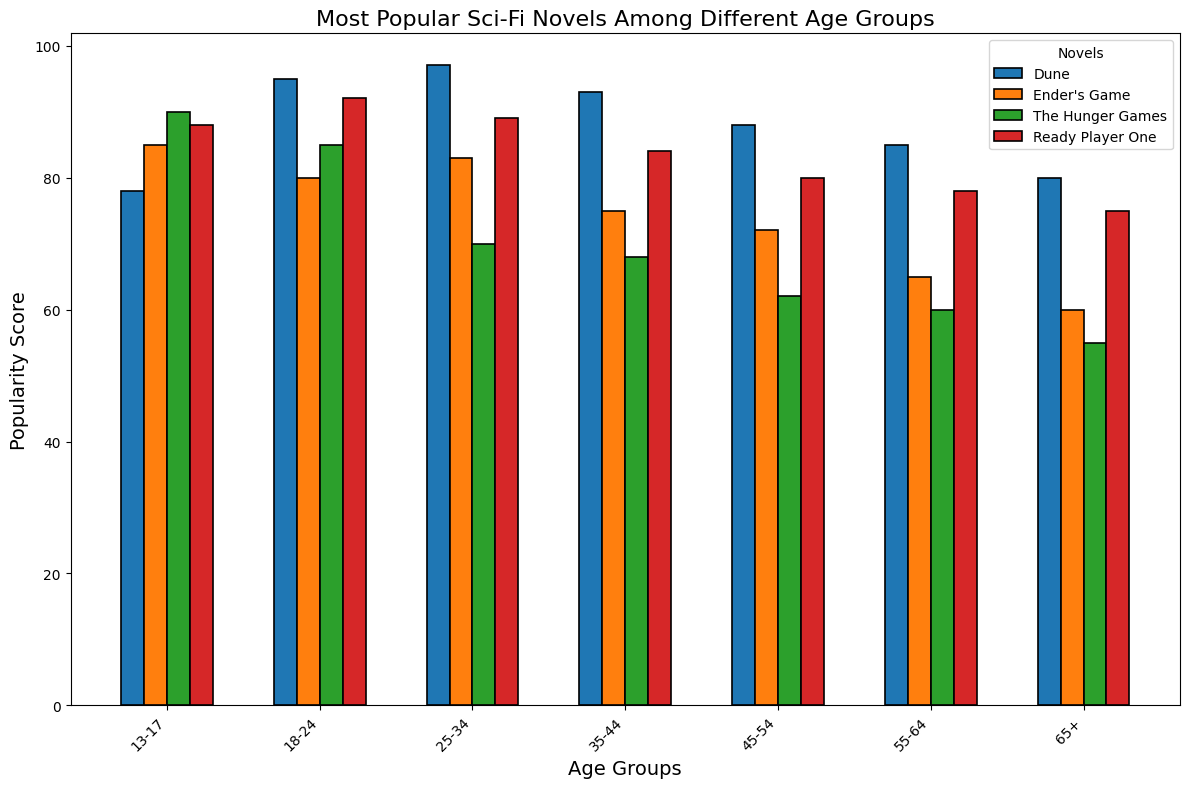Which age group finds "The Hunger Games" the least popular? Find the bar representing "The Hunger Games" for each age group. The bar with the smallest height corresponds to the least popular age group. For "The Hunger Games," the age group 65+ has the smallest bar.
Answer: 65+ By how many points is "Ready Player One" more popular among the 18-24 age group compared to the 13-17 age group? Find the height of "Ready Player One" bar for each age group. The popularity is 92 for 18-24 and 88 for 13-17. Subtract the smaller value from the larger one: 92 - 88 = 4.
Answer: 4 Which novel is the most popular among all age groups? Look for the highest bar across all novels and age groups. The tallest bar is for "Dune" in the 25-34 age group with a score of 97.
Answer: Dune What's the average popularity score of "Ender's Game" across all age groups? Sum up the popularity scores of "Ender's Game" for all age groups and divide by the number of age groups. (85 + 80 + 83 + 75 + 72 + 65 + 60)/7 = 74.
Answer: 74 Is "Dune" more popular in the 25-34 age group or the 55-64 age group? Compare the heights of the bars for "Dune" in the two age groups. The 25-34 age group has a score of 97, while the 55-64 age group has a score of 85. 97 is greater than 85.
Answer: 25-34 Which age group has the highest average popularity score across all novels? Calculate the average score for each age group by summing the scores for all novels in that age group and dividing by the number of novels. The averages are: 13-17: (78+85+90+88)/4 = 85.25; 18-24: (95+80+85+92)/4 = 88; 25-34: (97+83+70+89)/4 = 84.75; 35-44: (93+75+68+84)/4 = 80; 45-54: (88+72+62+80)/4 = 75.5; 55-64: (85+65+60+78)/4 = 72; 65+: (80+60+55+75)/4 = 67.5. The highest average is 88 for the 18-24 age group.
Answer: 18-24 How many novels have a popularity score above 80 in the 45-54 age group? Count the bars above the height representing a score of 80 in the 45-54 age group. Only "Dune" exceeds 80 out of the four novels in this age group.
Answer: 1 